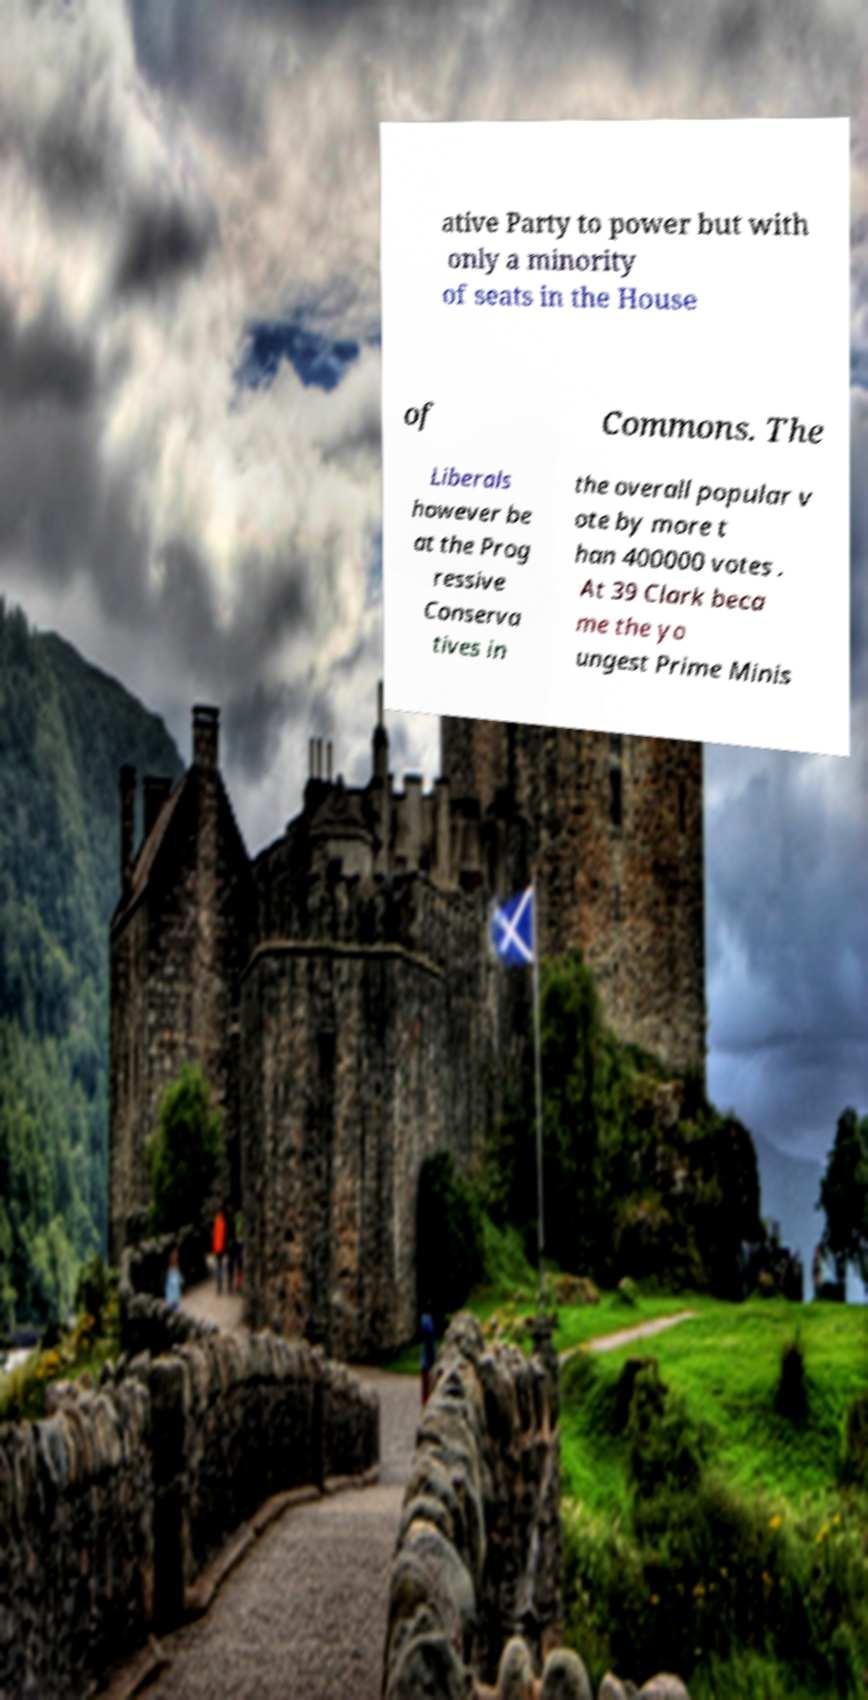Please identify and transcribe the text found in this image. ative Party to power but with only a minority of seats in the House of Commons. The Liberals however be at the Prog ressive Conserva tives in the overall popular v ote by more t han 400000 votes . At 39 Clark beca me the yo ungest Prime Minis 